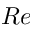Convert formula to latex. <formula><loc_0><loc_0><loc_500><loc_500>R e</formula> 